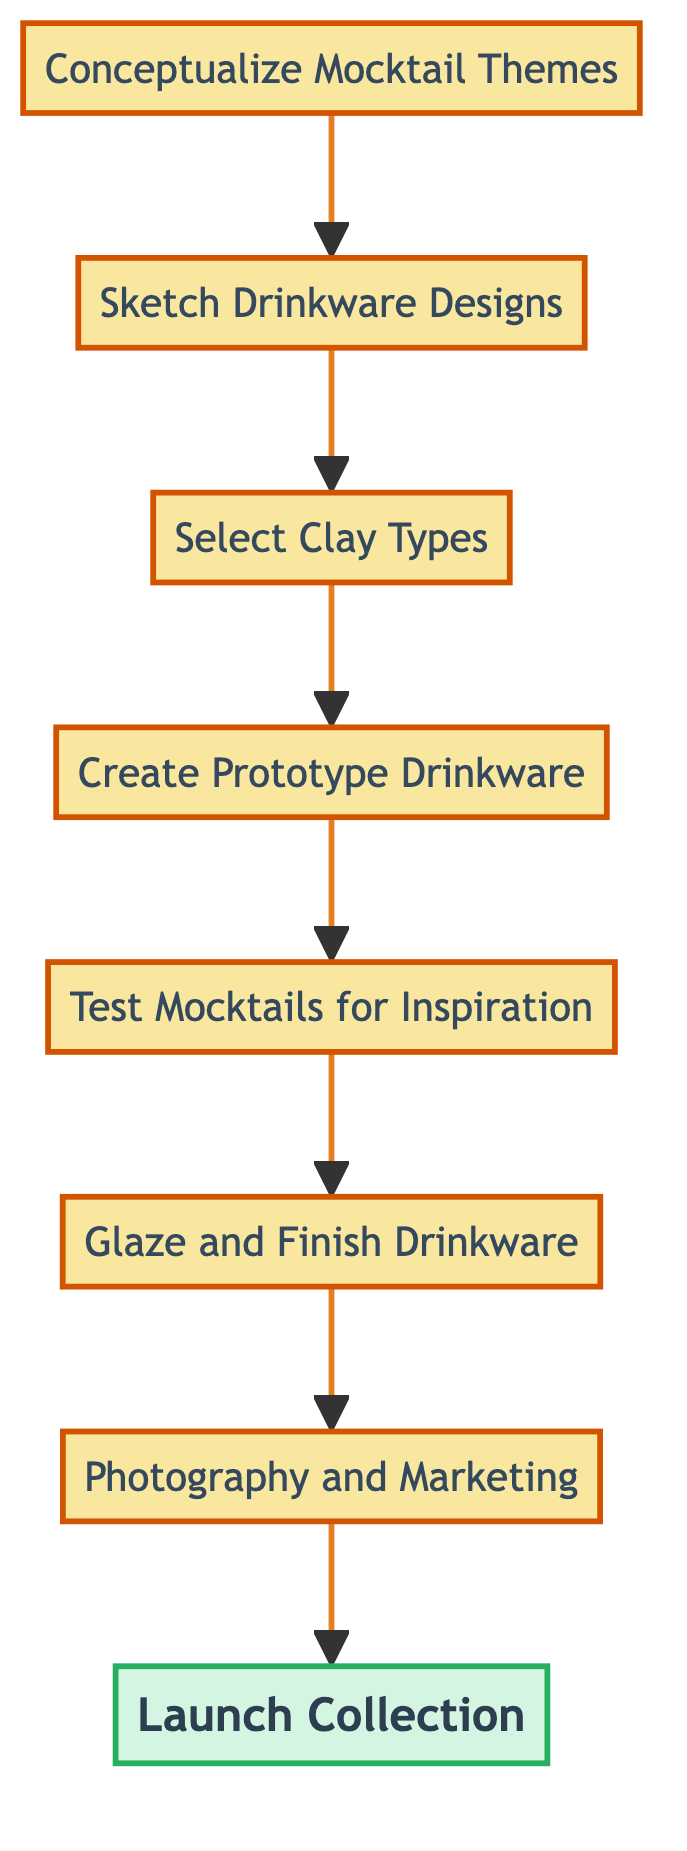What is the first step in the process? The diagram indicates that the first step is conceptualizing mocktail themes, as it is the topmost node.
Answer: Conceptualize Mocktail Themes How many steps are there in total? By counting all nodes from "Conceptualize Mocktail Themes" to "Launch Collection," there are eight steps in total.
Answer: 8 What step follows "Create Prototype Drinkware"? The step that follows "Create Prototype Drinkware" is "Test Mocktails for Inspiration," as indicated by the directional flow in the diagram.
Answer: Test Mocktails for Inspiration Which step includes applying glazes? The step that involves applying glazes is "Glaze and Finish Drinkware," as shown directly in the flow after testing the mocktails.
Answer: Glaze and Finish Drinkware What is the final step of the process? The final step indicated in the diagram for the process is "Launch Collection," located at the bottom of the flowchart.
Answer: Launch Collection Which step comes before "Photography and Marketing"? The step that comes before "Photography and Marketing" in the flow is "Glaze and Finish Drinkware," demonstrating the progression before marketing efforts.
Answer: Glaze and Finish Drinkware What is the relationship between "Sketch Drinkware Designs" and "Select Clay Types"? The relationship shows that "Sketch Drinkware Designs" leads into "Select Clay Types," indicating a sequential process where sketches determine clay selection.
Answer: Leads to In the context of this diagram, what is the purpose of "Test Mocktails for Inspiration"? This step serves to prepare and taste mocktails that inspire the final designs of the drinkware, showing its significance in triggering creative decisions.
Answer: Inspire final designs What type of diagram is used to represent the process? The diagram is a Bottom Up Flow Chart, which illustrates the sequential steps necessary for organizing the mocktail-inspired drinkware collection.
Answer: Bottom Up Flow Chart 